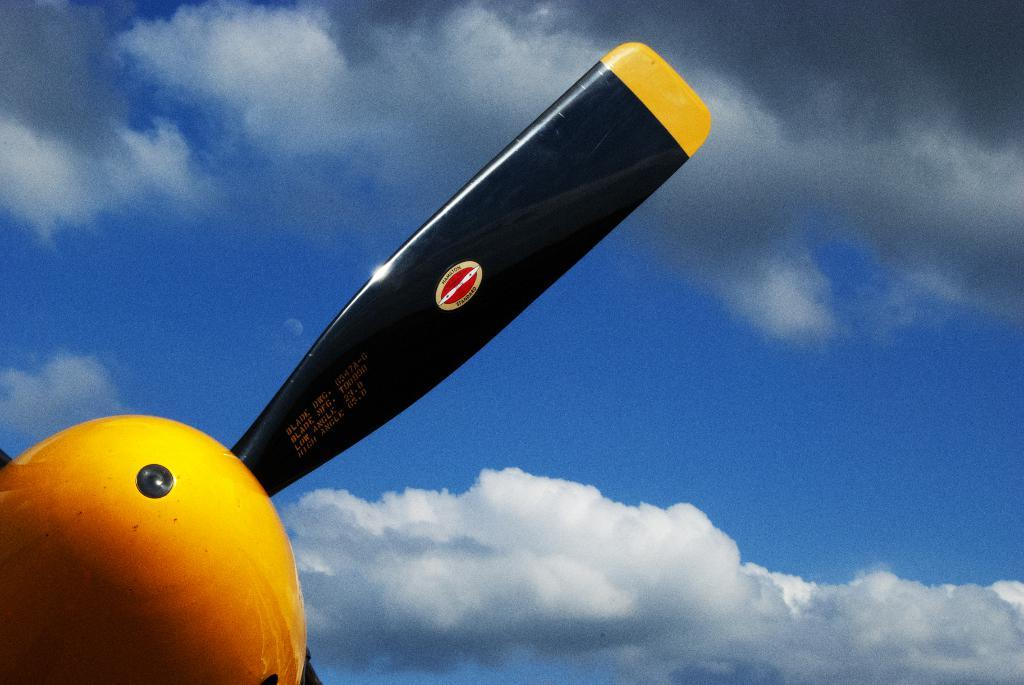What is the main subject of the image? The main subject of the image is a fan of an airplane. What can be seen in the background of the image? Clouds are present in the image. How many branches can be seen on the crow in the image? There is: There is no crow or branches present in the image; it features a fan of an airplane and clouds. 